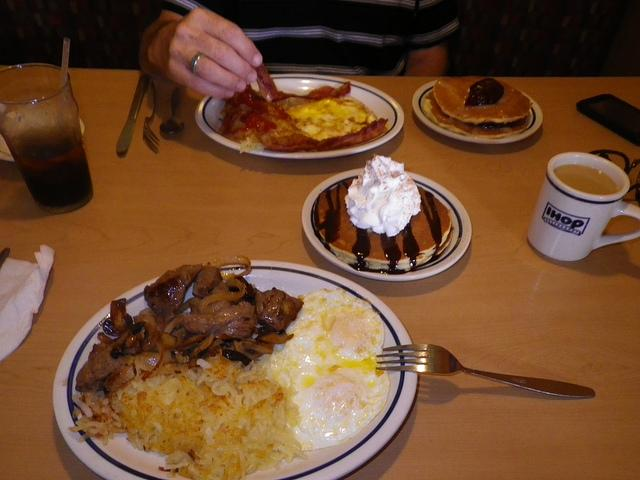What food on the table contains the highest amount of fat?

Choices:
A) bacon
B) rice
C) pancake
D) egg bacon 